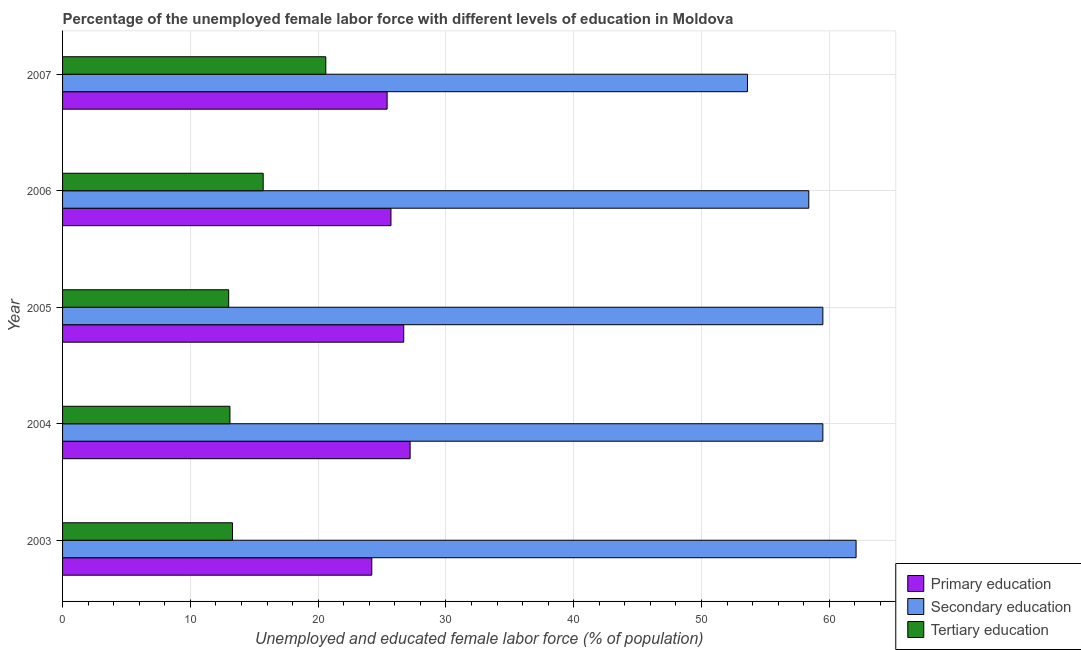How many different coloured bars are there?
Give a very brief answer. 3. Are the number of bars per tick equal to the number of legend labels?
Ensure brevity in your answer.  Yes. Are the number of bars on each tick of the Y-axis equal?
Make the answer very short. Yes. What is the percentage of female labor force who received tertiary education in 2006?
Keep it short and to the point. 15.7. Across all years, what is the maximum percentage of female labor force who received tertiary education?
Offer a very short reply. 20.6. Across all years, what is the minimum percentage of female labor force who received secondary education?
Your response must be concise. 53.6. In which year was the percentage of female labor force who received primary education maximum?
Provide a succinct answer. 2004. What is the total percentage of female labor force who received primary education in the graph?
Provide a succinct answer. 129.2. What is the difference between the percentage of female labor force who received secondary education in 2004 and that in 2007?
Provide a short and direct response. 5.9. What is the difference between the percentage of female labor force who received secondary education in 2003 and the percentage of female labor force who received primary education in 2007?
Offer a very short reply. 36.7. What is the average percentage of female labor force who received primary education per year?
Offer a terse response. 25.84. In the year 2007, what is the difference between the percentage of female labor force who received tertiary education and percentage of female labor force who received secondary education?
Provide a short and direct response. -33. What is the ratio of the percentage of female labor force who received primary education in 2003 to that in 2006?
Provide a succinct answer. 0.94. What is the difference between the highest and the second highest percentage of female labor force who received secondary education?
Give a very brief answer. 2.6. What is the difference between the highest and the lowest percentage of female labor force who received secondary education?
Provide a succinct answer. 8.5. Is the sum of the percentage of female labor force who received primary education in 2003 and 2007 greater than the maximum percentage of female labor force who received tertiary education across all years?
Your answer should be very brief. Yes. What does the 2nd bar from the top in 2005 represents?
Offer a terse response. Secondary education. What does the 3rd bar from the bottom in 2007 represents?
Your response must be concise. Tertiary education. How many bars are there?
Provide a succinct answer. 15. Are all the bars in the graph horizontal?
Make the answer very short. Yes. Are the values on the major ticks of X-axis written in scientific E-notation?
Keep it short and to the point. No. How many legend labels are there?
Offer a terse response. 3. What is the title of the graph?
Keep it short and to the point. Percentage of the unemployed female labor force with different levels of education in Moldova. Does "Natural gas sources" appear as one of the legend labels in the graph?
Keep it short and to the point. No. What is the label or title of the X-axis?
Offer a terse response. Unemployed and educated female labor force (% of population). What is the label or title of the Y-axis?
Give a very brief answer. Year. What is the Unemployed and educated female labor force (% of population) of Primary education in 2003?
Keep it short and to the point. 24.2. What is the Unemployed and educated female labor force (% of population) in Secondary education in 2003?
Your answer should be very brief. 62.1. What is the Unemployed and educated female labor force (% of population) in Tertiary education in 2003?
Your answer should be compact. 13.3. What is the Unemployed and educated female labor force (% of population) in Primary education in 2004?
Your answer should be very brief. 27.2. What is the Unemployed and educated female labor force (% of population) in Secondary education in 2004?
Keep it short and to the point. 59.5. What is the Unemployed and educated female labor force (% of population) of Tertiary education in 2004?
Ensure brevity in your answer.  13.1. What is the Unemployed and educated female labor force (% of population) of Primary education in 2005?
Ensure brevity in your answer.  26.7. What is the Unemployed and educated female labor force (% of population) of Secondary education in 2005?
Offer a terse response. 59.5. What is the Unemployed and educated female labor force (% of population) of Tertiary education in 2005?
Ensure brevity in your answer.  13. What is the Unemployed and educated female labor force (% of population) in Primary education in 2006?
Make the answer very short. 25.7. What is the Unemployed and educated female labor force (% of population) in Secondary education in 2006?
Keep it short and to the point. 58.4. What is the Unemployed and educated female labor force (% of population) of Tertiary education in 2006?
Offer a very short reply. 15.7. What is the Unemployed and educated female labor force (% of population) of Primary education in 2007?
Make the answer very short. 25.4. What is the Unemployed and educated female labor force (% of population) in Secondary education in 2007?
Your answer should be compact. 53.6. What is the Unemployed and educated female labor force (% of population) in Tertiary education in 2007?
Keep it short and to the point. 20.6. Across all years, what is the maximum Unemployed and educated female labor force (% of population) of Primary education?
Keep it short and to the point. 27.2. Across all years, what is the maximum Unemployed and educated female labor force (% of population) in Secondary education?
Your answer should be very brief. 62.1. Across all years, what is the maximum Unemployed and educated female labor force (% of population) of Tertiary education?
Make the answer very short. 20.6. Across all years, what is the minimum Unemployed and educated female labor force (% of population) of Primary education?
Offer a terse response. 24.2. Across all years, what is the minimum Unemployed and educated female labor force (% of population) of Secondary education?
Provide a succinct answer. 53.6. What is the total Unemployed and educated female labor force (% of population) in Primary education in the graph?
Provide a succinct answer. 129.2. What is the total Unemployed and educated female labor force (% of population) in Secondary education in the graph?
Your response must be concise. 293.1. What is the total Unemployed and educated female labor force (% of population) in Tertiary education in the graph?
Offer a terse response. 75.7. What is the difference between the Unemployed and educated female labor force (% of population) in Primary education in 2003 and that in 2004?
Make the answer very short. -3. What is the difference between the Unemployed and educated female labor force (% of population) of Tertiary education in 2003 and that in 2004?
Provide a short and direct response. 0.2. What is the difference between the Unemployed and educated female labor force (% of population) of Primary education in 2003 and that in 2006?
Your answer should be compact. -1.5. What is the difference between the Unemployed and educated female labor force (% of population) in Secondary education in 2003 and that in 2006?
Keep it short and to the point. 3.7. What is the difference between the Unemployed and educated female labor force (% of population) in Tertiary education in 2003 and that in 2006?
Make the answer very short. -2.4. What is the difference between the Unemployed and educated female labor force (% of population) in Primary education in 2003 and that in 2007?
Provide a short and direct response. -1.2. What is the difference between the Unemployed and educated female labor force (% of population) of Primary education in 2004 and that in 2005?
Make the answer very short. 0.5. What is the difference between the Unemployed and educated female labor force (% of population) of Secondary education in 2004 and that in 2006?
Offer a terse response. 1.1. What is the difference between the Unemployed and educated female labor force (% of population) in Primary education in 2004 and that in 2007?
Make the answer very short. 1.8. What is the difference between the Unemployed and educated female labor force (% of population) in Secondary education in 2004 and that in 2007?
Ensure brevity in your answer.  5.9. What is the difference between the Unemployed and educated female labor force (% of population) of Primary education in 2005 and that in 2006?
Ensure brevity in your answer.  1. What is the difference between the Unemployed and educated female labor force (% of population) of Secondary education in 2005 and that in 2007?
Provide a succinct answer. 5.9. What is the difference between the Unemployed and educated female labor force (% of population) in Tertiary education in 2005 and that in 2007?
Give a very brief answer. -7.6. What is the difference between the Unemployed and educated female labor force (% of population) in Secondary education in 2006 and that in 2007?
Offer a terse response. 4.8. What is the difference between the Unemployed and educated female labor force (% of population) of Primary education in 2003 and the Unemployed and educated female labor force (% of population) of Secondary education in 2004?
Keep it short and to the point. -35.3. What is the difference between the Unemployed and educated female labor force (% of population) in Secondary education in 2003 and the Unemployed and educated female labor force (% of population) in Tertiary education in 2004?
Make the answer very short. 49. What is the difference between the Unemployed and educated female labor force (% of population) in Primary education in 2003 and the Unemployed and educated female labor force (% of population) in Secondary education in 2005?
Give a very brief answer. -35.3. What is the difference between the Unemployed and educated female labor force (% of population) in Secondary education in 2003 and the Unemployed and educated female labor force (% of population) in Tertiary education in 2005?
Provide a short and direct response. 49.1. What is the difference between the Unemployed and educated female labor force (% of population) of Primary education in 2003 and the Unemployed and educated female labor force (% of population) of Secondary education in 2006?
Make the answer very short. -34.2. What is the difference between the Unemployed and educated female labor force (% of population) of Primary education in 2003 and the Unemployed and educated female labor force (% of population) of Tertiary education in 2006?
Provide a short and direct response. 8.5. What is the difference between the Unemployed and educated female labor force (% of population) of Secondary education in 2003 and the Unemployed and educated female labor force (% of population) of Tertiary education in 2006?
Keep it short and to the point. 46.4. What is the difference between the Unemployed and educated female labor force (% of population) in Primary education in 2003 and the Unemployed and educated female labor force (% of population) in Secondary education in 2007?
Give a very brief answer. -29.4. What is the difference between the Unemployed and educated female labor force (% of population) of Primary education in 2003 and the Unemployed and educated female labor force (% of population) of Tertiary education in 2007?
Your answer should be very brief. 3.6. What is the difference between the Unemployed and educated female labor force (% of population) in Secondary education in 2003 and the Unemployed and educated female labor force (% of population) in Tertiary education in 2007?
Offer a very short reply. 41.5. What is the difference between the Unemployed and educated female labor force (% of population) of Primary education in 2004 and the Unemployed and educated female labor force (% of population) of Secondary education in 2005?
Keep it short and to the point. -32.3. What is the difference between the Unemployed and educated female labor force (% of population) of Primary education in 2004 and the Unemployed and educated female labor force (% of population) of Tertiary education in 2005?
Make the answer very short. 14.2. What is the difference between the Unemployed and educated female labor force (% of population) of Secondary education in 2004 and the Unemployed and educated female labor force (% of population) of Tertiary education in 2005?
Give a very brief answer. 46.5. What is the difference between the Unemployed and educated female labor force (% of population) of Primary education in 2004 and the Unemployed and educated female labor force (% of population) of Secondary education in 2006?
Provide a succinct answer. -31.2. What is the difference between the Unemployed and educated female labor force (% of population) of Secondary education in 2004 and the Unemployed and educated female labor force (% of population) of Tertiary education in 2006?
Your response must be concise. 43.8. What is the difference between the Unemployed and educated female labor force (% of population) in Primary education in 2004 and the Unemployed and educated female labor force (% of population) in Secondary education in 2007?
Give a very brief answer. -26.4. What is the difference between the Unemployed and educated female labor force (% of population) of Primary education in 2004 and the Unemployed and educated female labor force (% of population) of Tertiary education in 2007?
Offer a very short reply. 6.6. What is the difference between the Unemployed and educated female labor force (% of population) in Secondary education in 2004 and the Unemployed and educated female labor force (% of population) in Tertiary education in 2007?
Make the answer very short. 38.9. What is the difference between the Unemployed and educated female labor force (% of population) in Primary education in 2005 and the Unemployed and educated female labor force (% of population) in Secondary education in 2006?
Offer a terse response. -31.7. What is the difference between the Unemployed and educated female labor force (% of population) of Secondary education in 2005 and the Unemployed and educated female labor force (% of population) of Tertiary education in 2006?
Your response must be concise. 43.8. What is the difference between the Unemployed and educated female labor force (% of population) in Primary education in 2005 and the Unemployed and educated female labor force (% of population) in Secondary education in 2007?
Your response must be concise. -26.9. What is the difference between the Unemployed and educated female labor force (% of population) in Primary education in 2005 and the Unemployed and educated female labor force (% of population) in Tertiary education in 2007?
Provide a short and direct response. 6.1. What is the difference between the Unemployed and educated female labor force (% of population) of Secondary education in 2005 and the Unemployed and educated female labor force (% of population) of Tertiary education in 2007?
Provide a short and direct response. 38.9. What is the difference between the Unemployed and educated female labor force (% of population) of Primary education in 2006 and the Unemployed and educated female labor force (% of population) of Secondary education in 2007?
Your answer should be very brief. -27.9. What is the difference between the Unemployed and educated female labor force (% of population) of Primary education in 2006 and the Unemployed and educated female labor force (% of population) of Tertiary education in 2007?
Your answer should be very brief. 5.1. What is the difference between the Unemployed and educated female labor force (% of population) of Secondary education in 2006 and the Unemployed and educated female labor force (% of population) of Tertiary education in 2007?
Make the answer very short. 37.8. What is the average Unemployed and educated female labor force (% of population) in Primary education per year?
Your answer should be compact. 25.84. What is the average Unemployed and educated female labor force (% of population) in Secondary education per year?
Offer a terse response. 58.62. What is the average Unemployed and educated female labor force (% of population) of Tertiary education per year?
Your answer should be very brief. 15.14. In the year 2003, what is the difference between the Unemployed and educated female labor force (% of population) in Primary education and Unemployed and educated female labor force (% of population) in Secondary education?
Ensure brevity in your answer.  -37.9. In the year 2003, what is the difference between the Unemployed and educated female labor force (% of population) in Secondary education and Unemployed and educated female labor force (% of population) in Tertiary education?
Provide a short and direct response. 48.8. In the year 2004, what is the difference between the Unemployed and educated female labor force (% of population) of Primary education and Unemployed and educated female labor force (% of population) of Secondary education?
Offer a very short reply. -32.3. In the year 2004, what is the difference between the Unemployed and educated female labor force (% of population) in Secondary education and Unemployed and educated female labor force (% of population) in Tertiary education?
Offer a terse response. 46.4. In the year 2005, what is the difference between the Unemployed and educated female labor force (% of population) of Primary education and Unemployed and educated female labor force (% of population) of Secondary education?
Make the answer very short. -32.8. In the year 2005, what is the difference between the Unemployed and educated female labor force (% of population) of Primary education and Unemployed and educated female labor force (% of population) of Tertiary education?
Your answer should be compact. 13.7. In the year 2005, what is the difference between the Unemployed and educated female labor force (% of population) in Secondary education and Unemployed and educated female labor force (% of population) in Tertiary education?
Give a very brief answer. 46.5. In the year 2006, what is the difference between the Unemployed and educated female labor force (% of population) of Primary education and Unemployed and educated female labor force (% of population) of Secondary education?
Ensure brevity in your answer.  -32.7. In the year 2006, what is the difference between the Unemployed and educated female labor force (% of population) of Primary education and Unemployed and educated female labor force (% of population) of Tertiary education?
Your answer should be very brief. 10. In the year 2006, what is the difference between the Unemployed and educated female labor force (% of population) in Secondary education and Unemployed and educated female labor force (% of population) in Tertiary education?
Offer a very short reply. 42.7. In the year 2007, what is the difference between the Unemployed and educated female labor force (% of population) in Primary education and Unemployed and educated female labor force (% of population) in Secondary education?
Offer a very short reply. -28.2. What is the ratio of the Unemployed and educated female labor force (% of population) in Primary education in 2003 to that in 2004?
Offer a terse response. 0.89. What is the ratio of the Unemployed and educated female labor force (% of population) in Secondary education in 2003 to that in 2004?
Provide a succinct answer. 1.04. What is the ratio of the Unemployed and educated female labor force (% of population) in Tertiary education in 2003 to that in 2004?
Provide a succinct answer. 1.02. What is the ratio of the Unemployed and educated female labor force (% of population) in Primary education in 2003 to that in 2005?
Give a very brief answer. 0.91. What is the ratio of the Unemployed and educated female labor force (% of population) of Secondary education in 2003 to that in 2005?
Ensure brevity in your answer.  1.04. What is the ratio of the Unemployed and educated female labor force (% of population) in Tertiary education in 2003 to that in 2005?
Offer a very short reply. 1.02. What is the ratio of the Unemployed and educated female labor force (% of population) of Primary education in 2003 to that in 2006?
Ensure brevity in your answer.  0.94. What is the ratio of the Unemployed and educated female labor force (% of population) in Secondary education in 2003 to that in 2006?
Keep it short and to the point. 1.06. What is the ratio of the Unemployed and educated female labor force (% of population) of Tertiary education in 2003 to that in 2006?
Make the answer very short. 0.85. What is the ratio of the Unemployed and educated female labor force (% of population) in Primary education in 2003 to that in 2007?
Provide a succinct answer. 0.95. What is the ratio of the Unemployed and educated female labor force (% of population) of Secondary education in 2003 to that in 2007?
Your answer should be very brief. 1.16. What is the ratio of the Unemployed and educated female labor force (% of population) in Tertiary education in 2003 to that in 2007?
Keep it short and to the point. 0.65. What is the ratio of the Unemployed and educated female labor force (% of population) in Primary education in 2004 to that in 2005?
Ensure brevity in your answer.  1.02. What is the ratio of the Unemployed and educated female labor force (% of population) in Secondary education in 2004 to that in 2005?
Make the answer very short. 1. What is the ratio of the Unemployed and educated female labor force (% of population) in Tertiary education in 2004 to that in 2005?
Provide a succinct answer. 1.01. What is the ratio of the Unemployed and educated female labor force (% of population) in Primary education in 2004 to that in 2006?
Provide a succinct answer. 1.06. What is the ratio of the Unemployed and educated female labor force (% of population) of Secondary education in 2004 to that in 2006?
Provide a short and direct response. 1.02. What is the ratio of the Unemployed and educated female labor force (% of population) of Tertiary education in 2004 to that in 2006?
Your response must be concise. 0.83. What is the ratio of the Unemployed and educated female labor force (% of population) of Primary education in 2004 to that in 2007?
Provide a short and direct response. 1.07. What is the ratio of the Unemployed and educated female labor force (% of population) in Secondary education in 2004 to that in 2007?
Ensure brevity in your answer.  1.11. What is the ratio of the Unemployed and educated female labor force (% of population) of Tertiary education in 2004 to that in 2007?
Provide a succinct answer. 0.64. What is the ratio of the Unemployed and educated female labor force (% of population) in Primary education in 2005 to that in 2006?
Ensure brevity in your answer.  1.04. What is the ratio of the Unemployed and educated female labor force (% of population) in Secondary education in 2005 to that in 2006?
Ensure brevity in your answer.  1.02. What is the ratio of the Unemployed and educated female labor force (% of population) of Tertiary education in 2005 to that in 2006?
Keep it short and to the point. 0.83. What is the ratio of the Unemployed and educated female labor force (% of population) of Primary education in 2005 to that in 2007?
Your answer should be very brief. 1.05. What is the ratio of the Unemployed and educated female labor force (% of population) in Secondary education in 2005 to that in 2007?
Your response must be concise. 1.11. What is the ratio of the Unemployed and educated female labor force (% of population) in Tertiary education in 2005 to that in 2007?
Your response must be concise. 0.63. What is the ratio of the Unemployed and educated female labor force (% of population) of Primary education in 2006 to that in 2007?
Your response must be concise. 1.01. What is the ratio of the Unemployed and educated female labor force (% of population) in Secondary education in 2006 to that in 2007?
Ensure brevity in your answer.  1.09. What is the ratio of the Unemployed and educated female labor force (% of population) of Tertiary education in 2006 to that in 2007?
Provide a succinct answer. 0.76. What is the difference between the highest and the second highest Unemployed and educated female labor force (% of population) in Secondary education?
Give a very brief answer. 2.6. What is the difference between the highest and the second highest Unemployed and educated female labor force (% of population) of Tertiary education?
Provide a succinct answer. 4.9. What is the difference between the highest and the lowest Unemployed and educated female labor force (% of population) of Primary education?
Provide a short and direct response. 3. What is the difference between the highest and the lowest Unemployed and educated female labor force (% of population) of Secondary education?
Your answer should be compact. 8.5. What is the difference between the highest and the lowest Unemployed and educated female labor force (% of population) in Tertiary education?
Your answer should be compact. 7.6. 